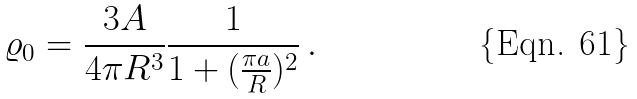Convert formula to latex. <formula><loc_0><loc_0><loc_500><loc_500>\varrho _ { 0 } = \frac { 3 A } { 4 \pi R ^ { 3 } } \frac { 1 } { 1 + ( \frac { \pi a } { R } ) ^ { 2 } } \, .</formula> 